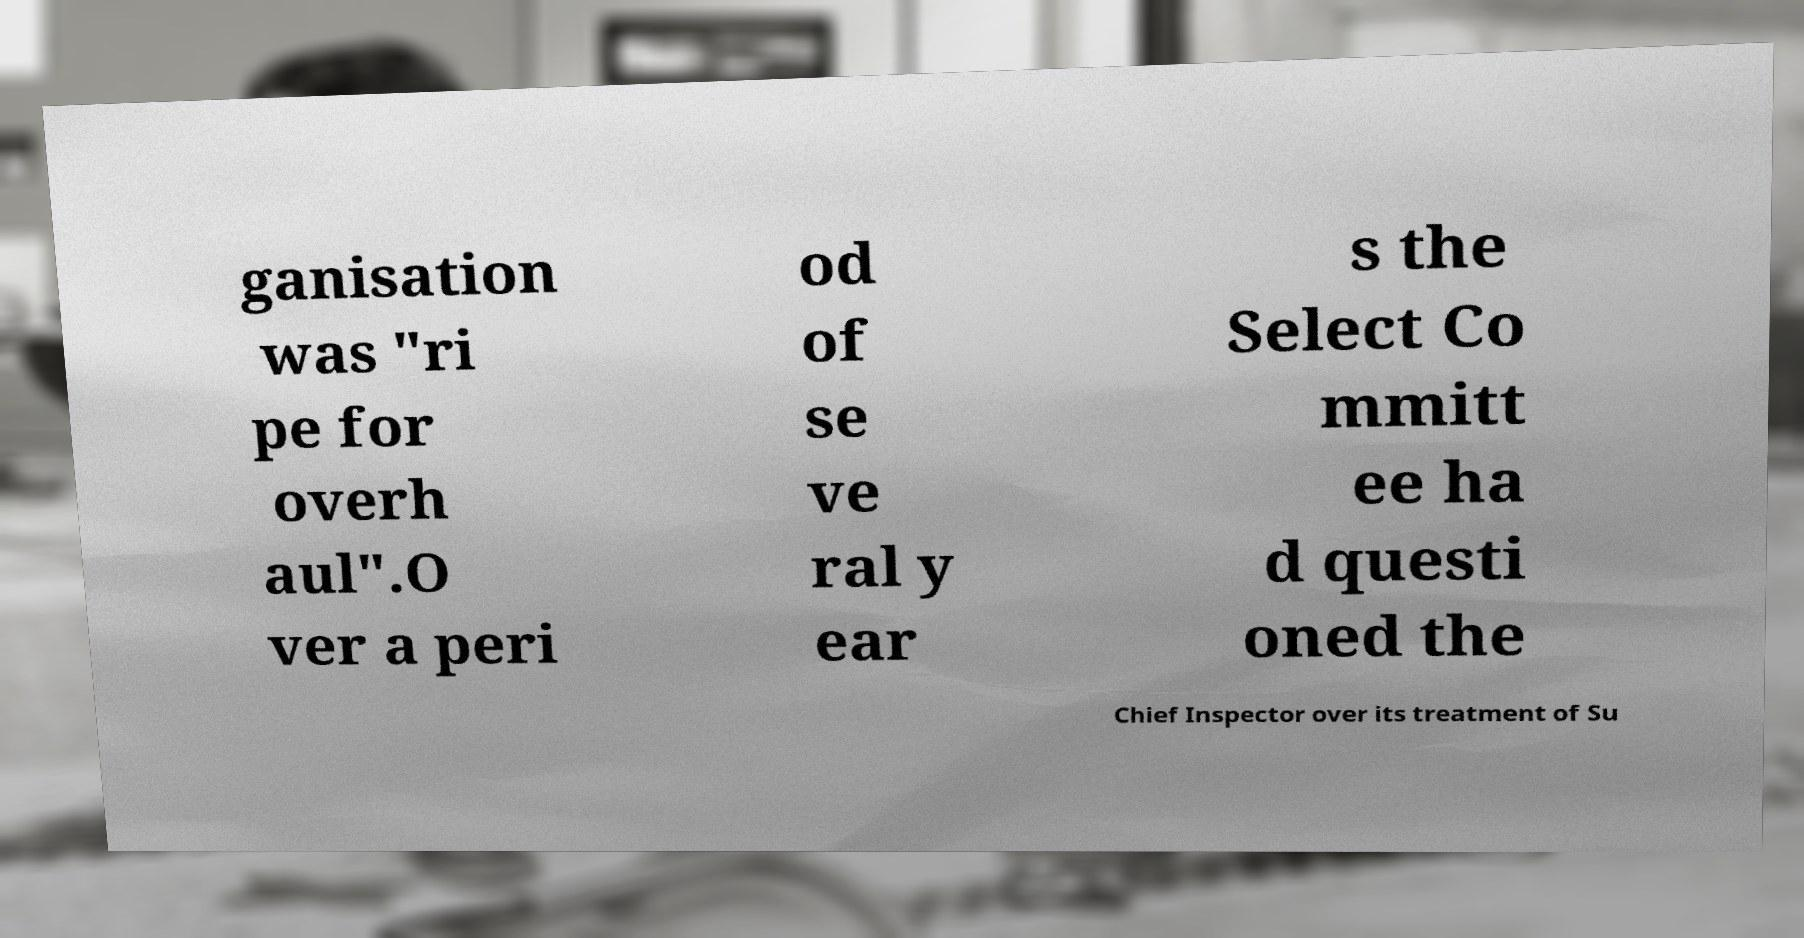Can you read and provide the text displayed in the image?This photo seems to have some interesting text. Can you extract and type it out for me? ganisation was "ri pe for overh aul".O ver a peri od of se ve ral y ear s the Select Co mmitt ee ha d questi oned the Chief Inspector over its treatment of Su 